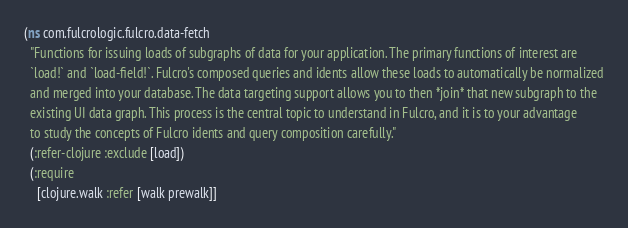<code> <loc_0><loc_0><loc_500><loc_500><_Clojure_>(ns com.fulcrologic.fulcro.data-fetch
  "Functions for issuing loads of subgraphs of data for your application. The primary functions of interest are
  `load!` and `load-field!`. Fulcro's composed queries and idents allow these loads to automatically be normalized
  and merged into your database. The data targeting support allows you to then *join* that new subgraph to the
  existing UI data graph. This process is the central topic to understand in Fulcro, and it is to your advantage
  to study the concepts of Fulcro idents and query composition carefully."
  (:refer-clojure :exclude [load])
  (:require
    [clojure.walk :refer [walk prewalk]]</code> 